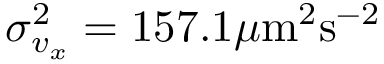Convert formula to latex. <formula><loc_0><loc_0><loc_500><loc_500>\sigma _ { v _ { x } } ^ { 2 } = 1 5 7 . 1 \mu m ^ { 2 } s ^ { - 2 }</formula> 